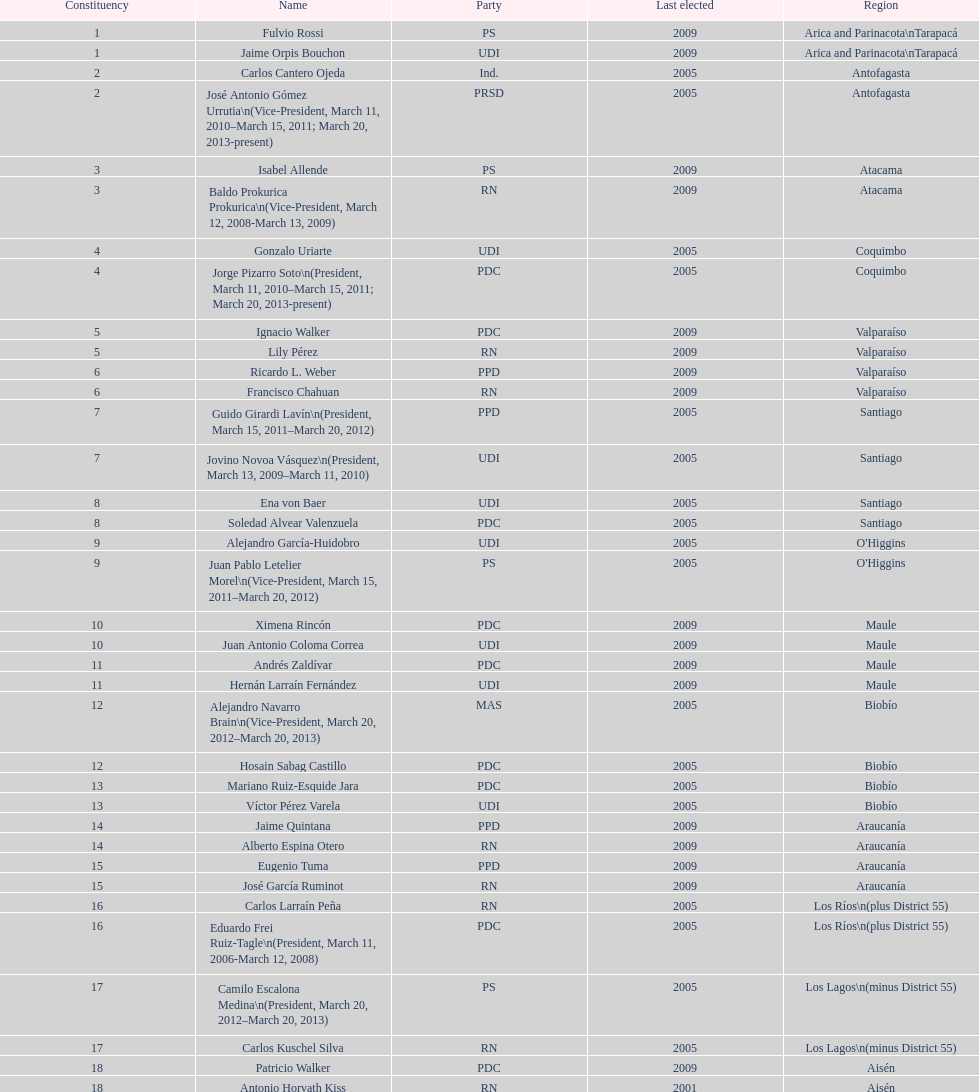Who was not last elected in either 2005 or 2009? Antonio Horvath Kiss. 